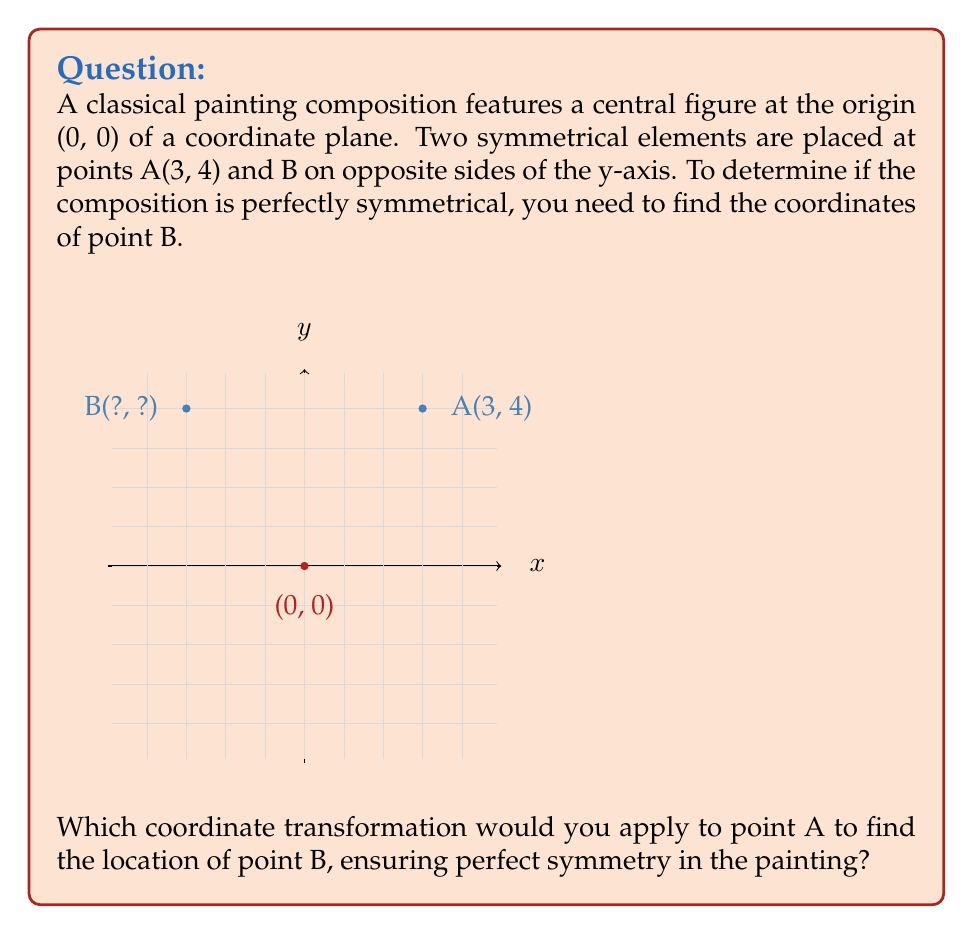Help me with this question. To determine the symmetry of the classical painting composition, we need to apply a reflection transformation across the y-axis. This is because the y-axis acts as the line of symmetry in this composition.

Step 1: Identify the transformation
The transformation we need is a reflection across the y-axis. This can be represented by the matrix:
$$\begin{pmatrix} -1 & 0 \\ 0 & 1 \end{pmatrix}$$

Step 2: Apply the transformation
To apply this transformation to point A(3, 4), we multiply the transformation matrix by the coordinate vector:

$$\begin{pmatrix} -1 & 0 \\ 0 & 1 \end{pmatrix} \begin{pmatrix} 3 \\ 4 \end{pmatrix} = \begin{pmatrix} (-1)(3) + (0)(4) \\ (0)(3) + (1)(4) \end{pmatrix} = \begin{pmatrix} -3 \\ 4 \end{pmatrix}$$

Step 3: Interpret the result
The resulting vector $(-3, 4)$ represents the coordinates of point B.

This transformation effectively flips the x-coordinate while keeping the y-coordinate the same, which is exactly what a reflection across the y-axis does.

Step 4: Verify symmetry
To confirm perfect symmetry, we can check that:
1. The y-coordinates of A and B are the same (4 in both cases).
2. The x-coordinates have the same absolute value but opposite signs (3 and -3).
3. The distance from each point to the y-axis is the same (3 units for both A and B).

These conditions ensure that the composition is perfectly symmetrical about the y-axis.
Answer: Reflection across y-axis: $(-x, y)$ 